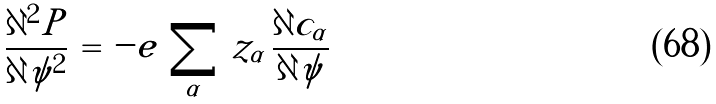Convert formula to latex. <formula><loc_0><loc_0><loc_500><loc_500>\frac { \partial ^ { 2 } P } { \partial \psi ^ { 2 } } \, = \, - e \, \sum _ { \alpha } \, z _ { \alpha } \, \frac { \partial c _ { \alpha } } { \partial \psi }</formula> 